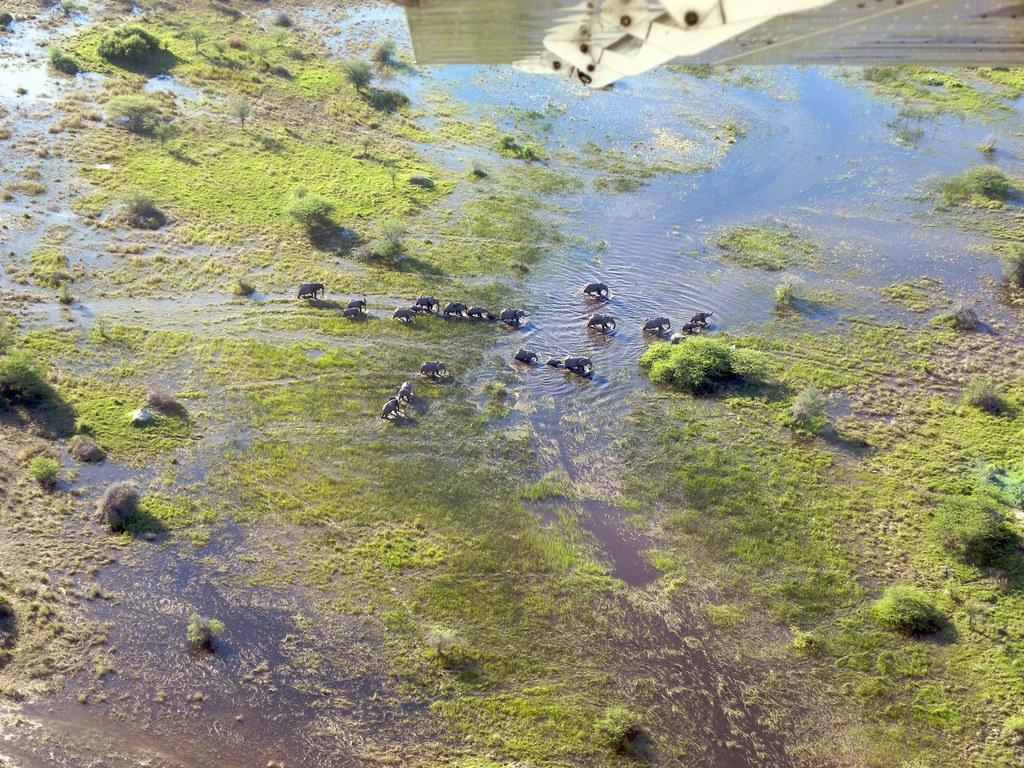What type of view is shown in the image? The image is an aerial view of a water body. What animals can be seen in the image? There are elephants in the center of the image. What type of vegetation is visible in the image? There are plants visible in the image. What type of ground cover is visible in the image? There is grass visible in the image. What natural element is the main focus of the image? There is water visible in the image. What type of kite is being flown by the elephants in the image? There are no kites visible in the image; it features an aerial view of a water body with elephants, plants, grass, and water. What side of the water body are the elephants standing on in the image? The image is an aerial view, so it does not have a specific side or direction. The elephants are in the center of the image, surrounded by water, plants, and grass. 